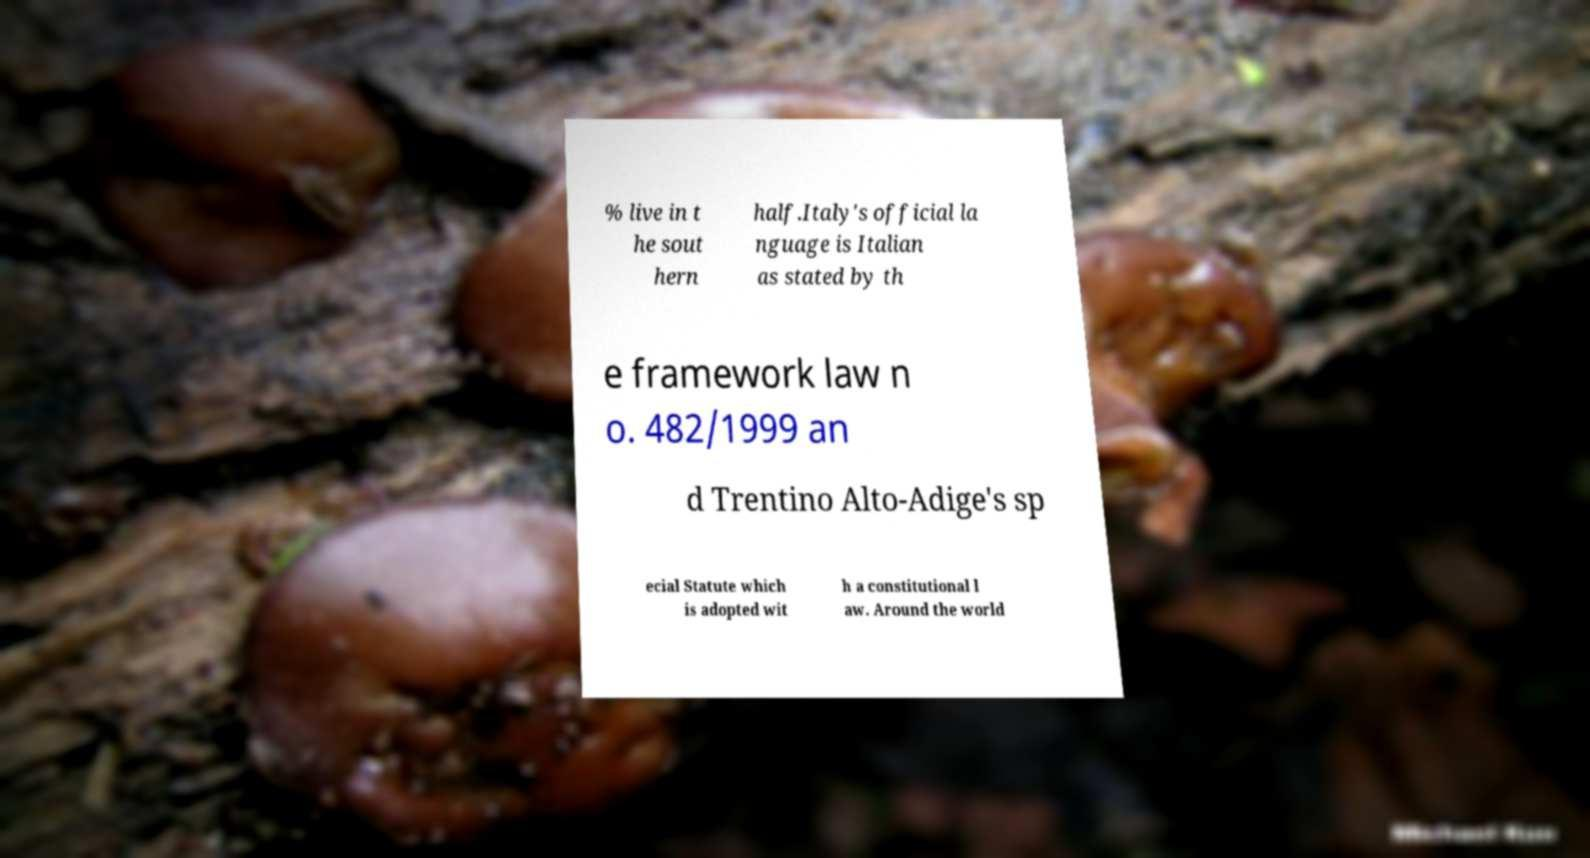For documentation purposes, I need the text within this image transcribed. Could you provide that? % live in t he sout hern half.Italy's official la nguage is Italian as stated by th e framework law n o. 482/1999 an d Trentino Alto-Adige's sp ecial Statute which is adopted wit h a constitutional l aw. Around the world 